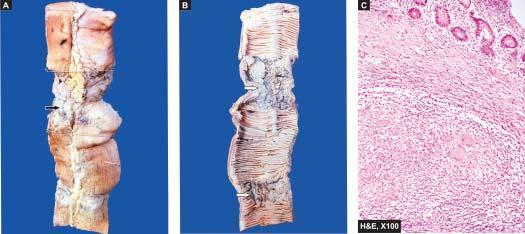what shows stricture and a lymph node in section having caseation necrosiss?
Answer the question using a single word or phrase. External surface of small intestine 